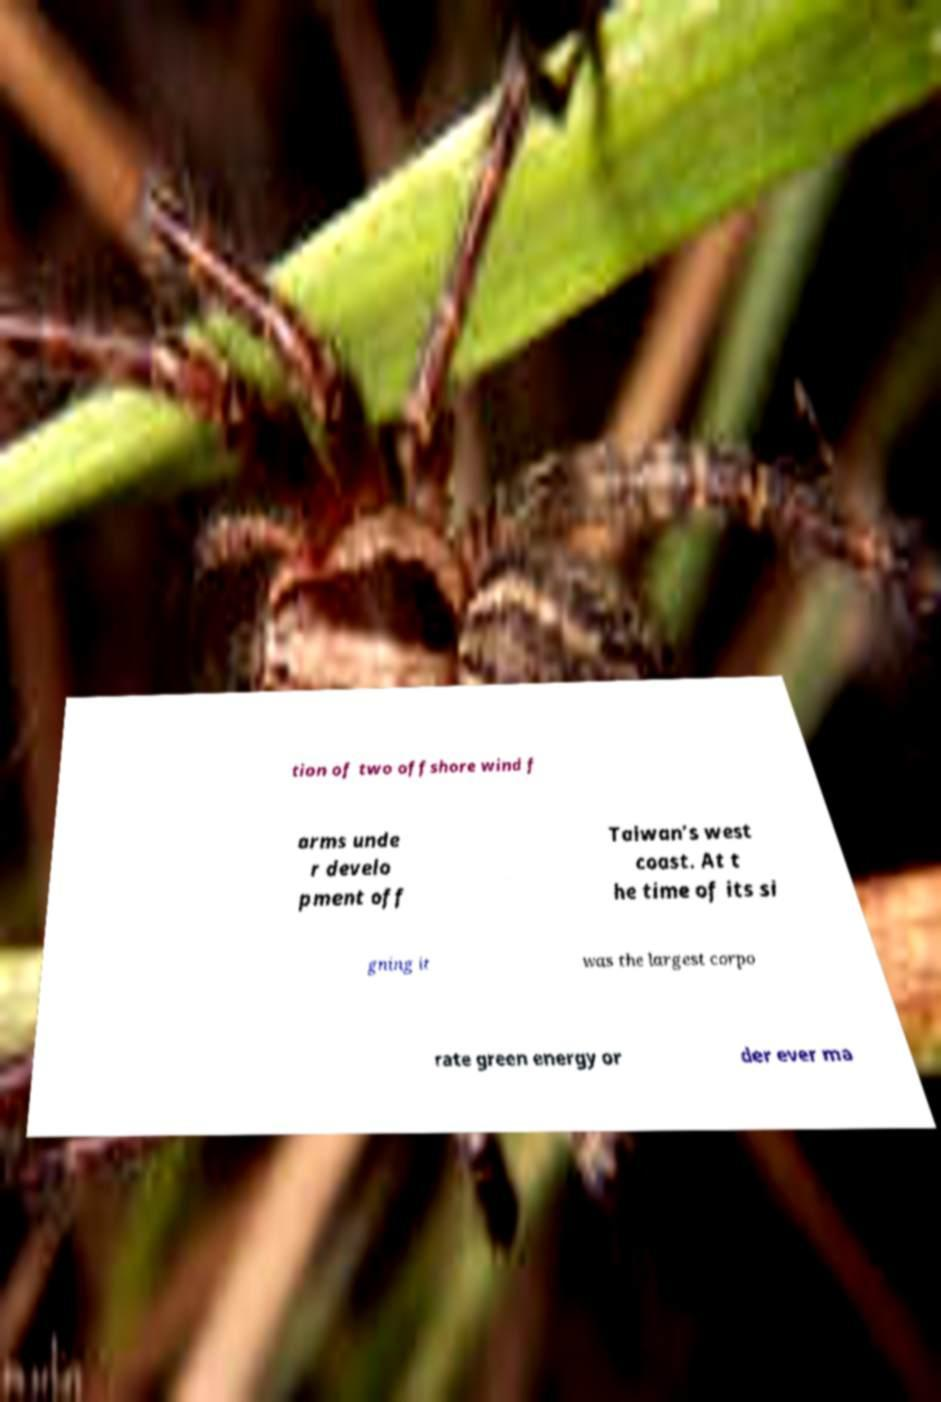Can you read and provide the text displayed in the image?This photo seems to have some interesting text. Can you extract and type it out for me? tion of two offshore wind f arms unde r develo pment off Taiwan’s west coast. At t he time of its si gning it was the largest corpo rate green energy or der ever ma 